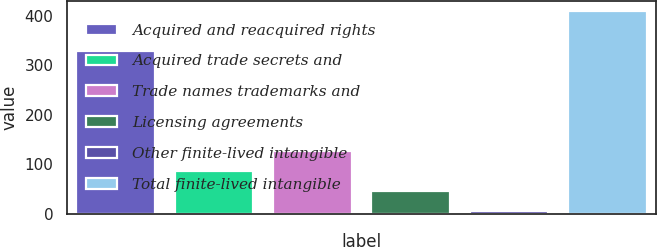Convert chart to OTSL. <chart><loc_0><loc_0><loc_500><loc_500><bar_chart><fcel>Acquired and reacquired rights<fcel>Acquired trade secrets and<fcel>Trade names trademarks and<fcel>Licensing agreements<fcel>Other finite-lived intangible<fcel>Total finite-lived intangible<nl><fcel>328.8<fcel>87.16<fcel>127.39<fcel>46.93<fcel>6.7<fcel>409<nl></chart> 